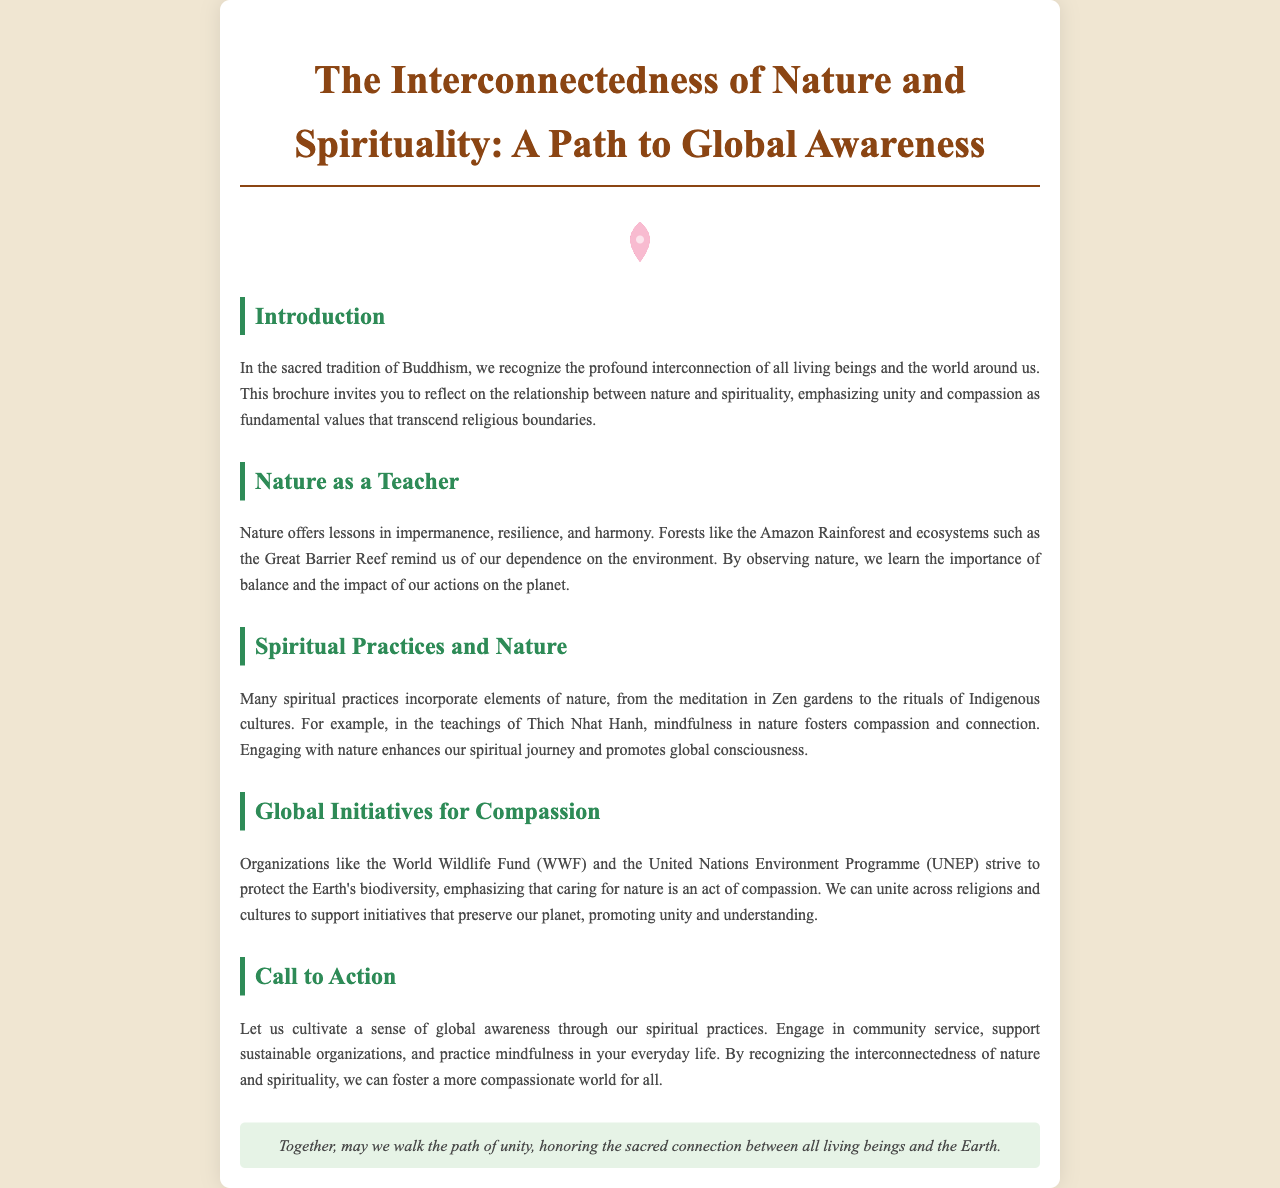What is the title of the brochure? The title is presented at the top of the document, summarizing its core theme.
Answer: The Interconnectedness of Nature and Spirituality: A Path to Global Awareness Who is recognized as a teacher in the document? The document states that nature offers important lessons, referring to it as a teacher.
Answer: Nature Which rainforest is mentioned in the brochure? The text specifically highlights a significant rainforest when discussing nature's lessons.
Answer: Amazon Rainforest What organization is mentioned as striving to protect biodiversity? The document lists an organization that focuses on environmental protection as a key component of its message.
Answer: World Wildlife Fund (WWF) What does mindfulness in nature foster according to Thich Nhat Hanh's teachings? The document explains the outcome of engaging in mindfulness within the natural world.
Answer: Compassion What does the brochure suggest we cultivate through spiritual practices? The document emphasizes a specific concept that should be developed through spiritual engagement and awareness.
Answer: Global awareness What type of practices are incorporated with elements of nature? The document discusses specific actions that blend spirituality with the environment.
Answer: Spiritual practices What does the footer of the brochure express? The final statement of the document encapsulates its overarching message about unity and connection.
Answer: Unity 